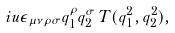<formula> <loc_0><loc_0><loc_500><loc_500>i u \epsilon _ { \mu \nu \rho \sigma } q _ { 1 } ^ { \rho } q _ { 2 } ^ { \sigma } \, T ( q _ { 1 } ^ { 2 } , q _ { 2 } ^ { 2 } ) ,</formula> 